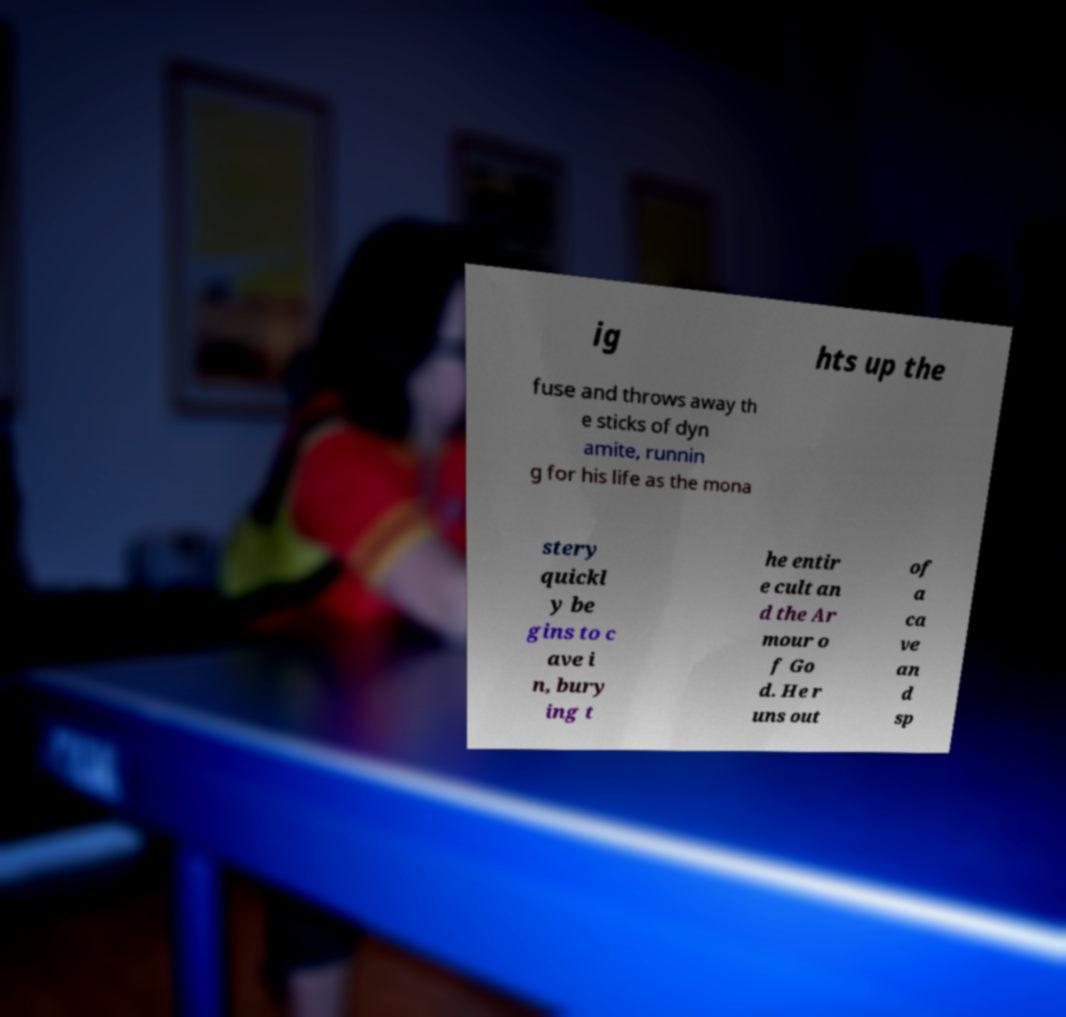Please identify and transcribe the text found in this image. ig hts up the fuse and throws away th e sticks of dyn amite, runnin g for his life as the mona stery quickl y be gins to c ave i n, bury ing t he entir e cult an d the Ar mour o f Go d. He r uns out of a ca ve an d sp 